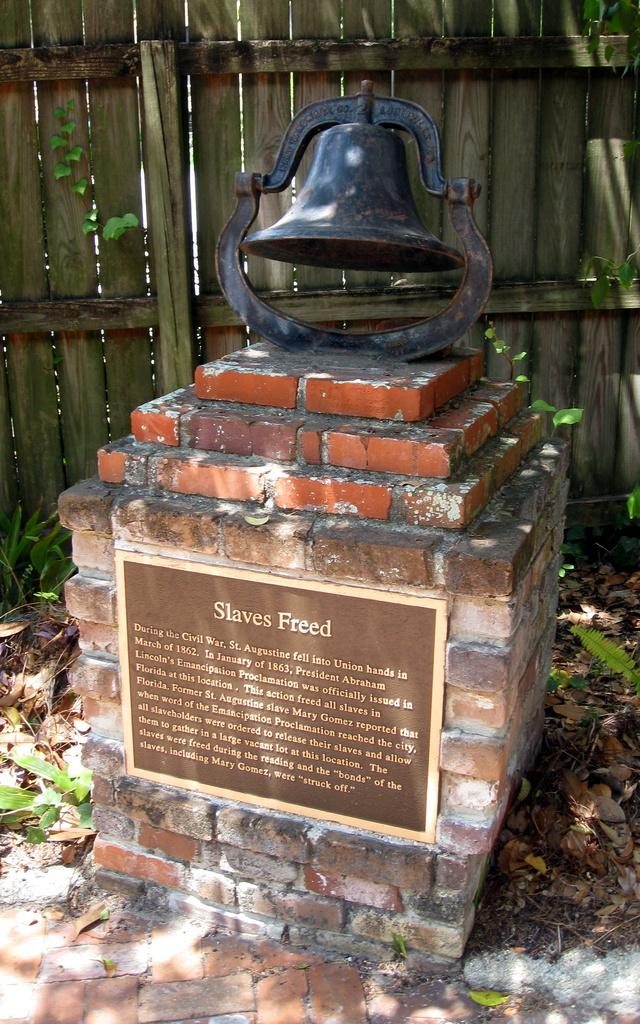What type of structure is in the image? There is a memorial in the image. What is the board used for in the image? The board is in the image, but its purpose is not specified. What is the bell associated with in the image? The bell is in the image, but its association with the memorial is not specified. What type of barrier surrounds the memorial in the image? There is a wooden fence in the image. What type of vegetation is present in the image? Dry leaves and grass are present in the image. What type of wax is used to clean the bell in the image? There is no wax or cleaning activity involving the bell in the image. How is the bucket used in the image? There is no bucket present in the image. 